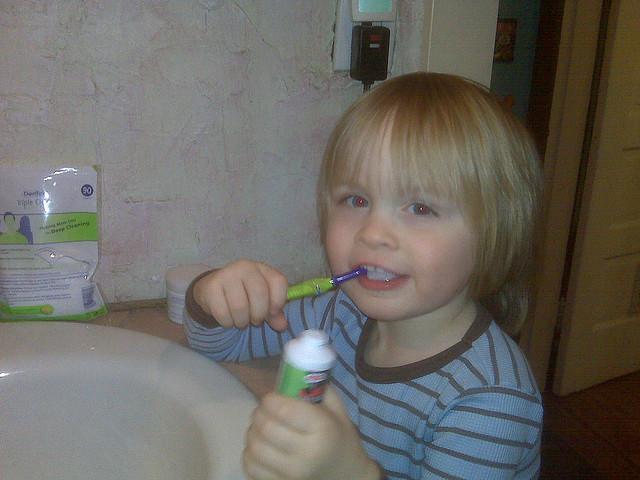How many people are in the picture?
Give a very brief answer. 2. How many black railroad cars are at the train station?
Give a very brief answer. 0. 